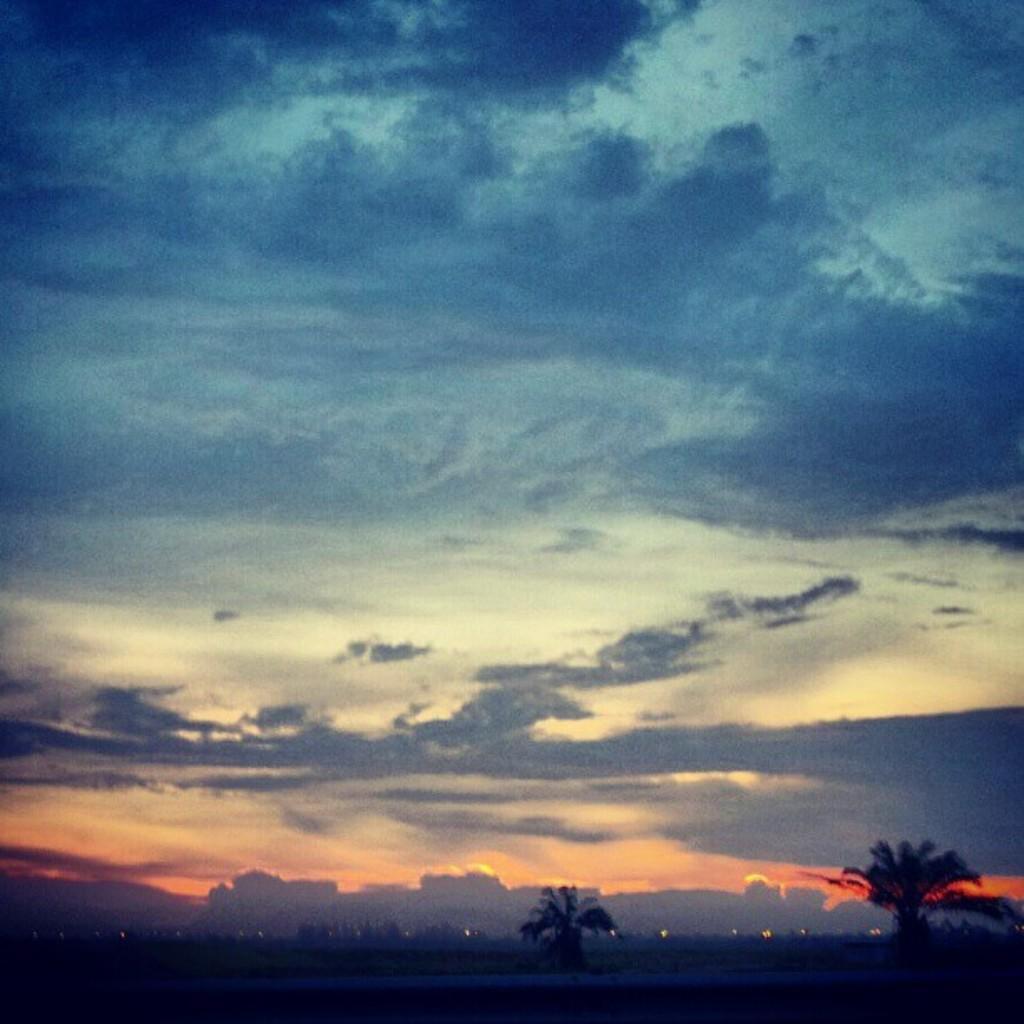How would you summarize this image in a sentence or two? In this picture I can see trees, buildings and I can see a blue cloudy sky. 